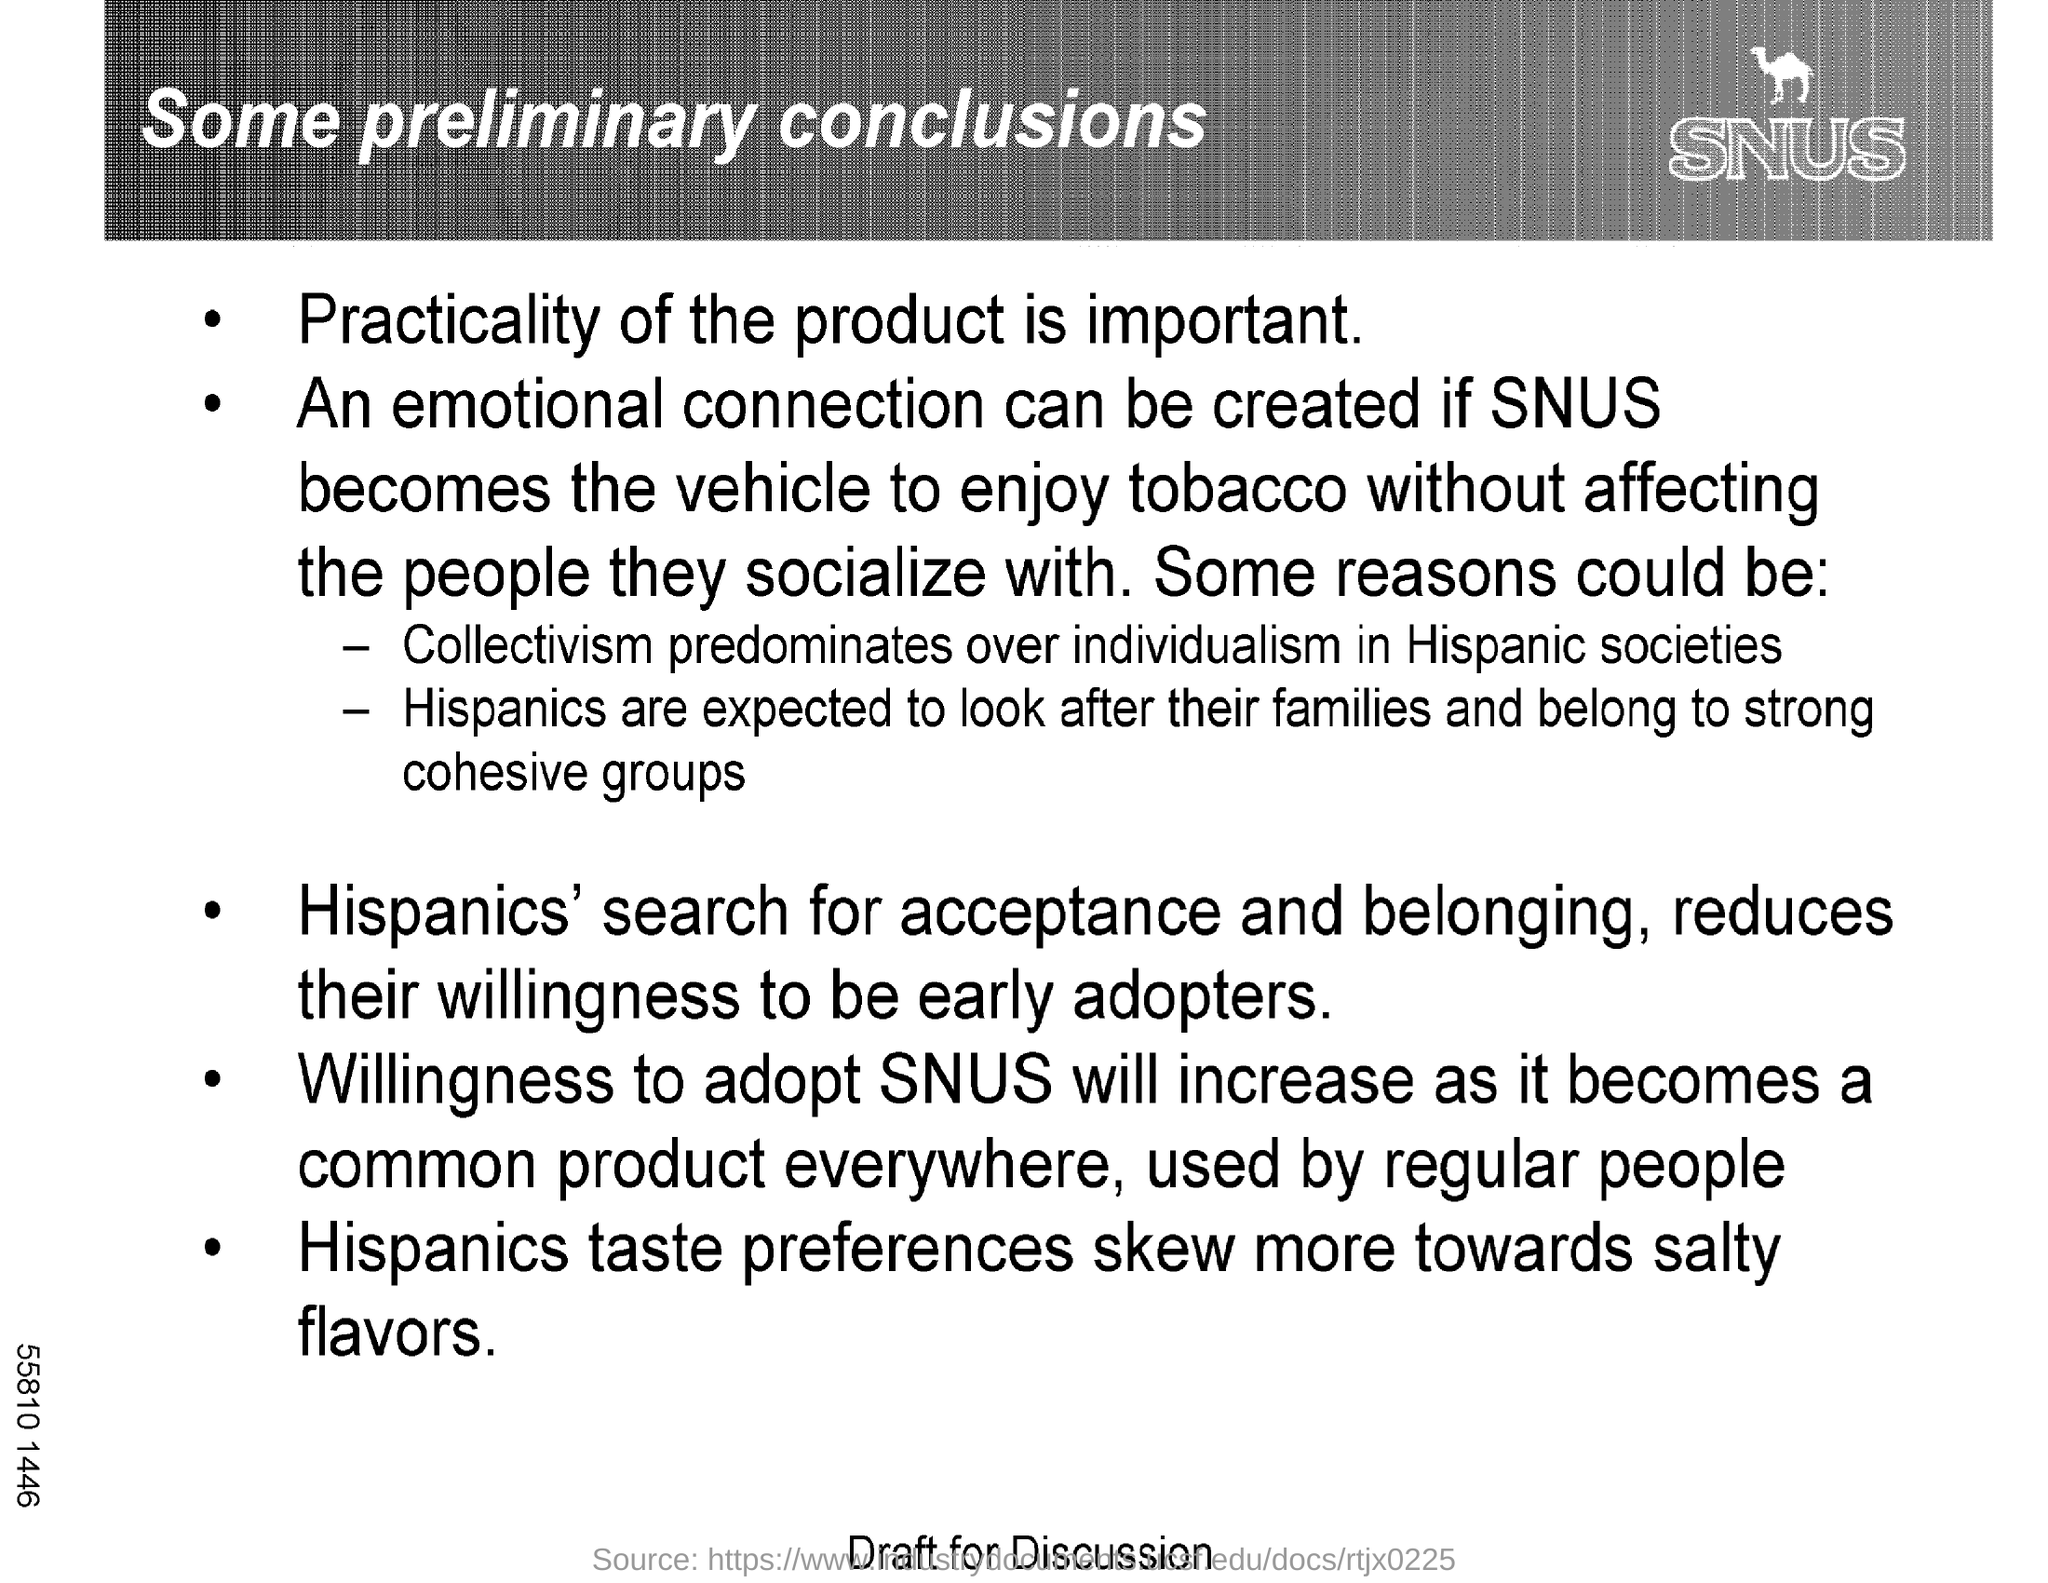What is the title of this document?
Your response must be concise. Some preliminary Conclusions. What flavors does Hispanics Prefer?
Make the answer very short. Salty flavors. 